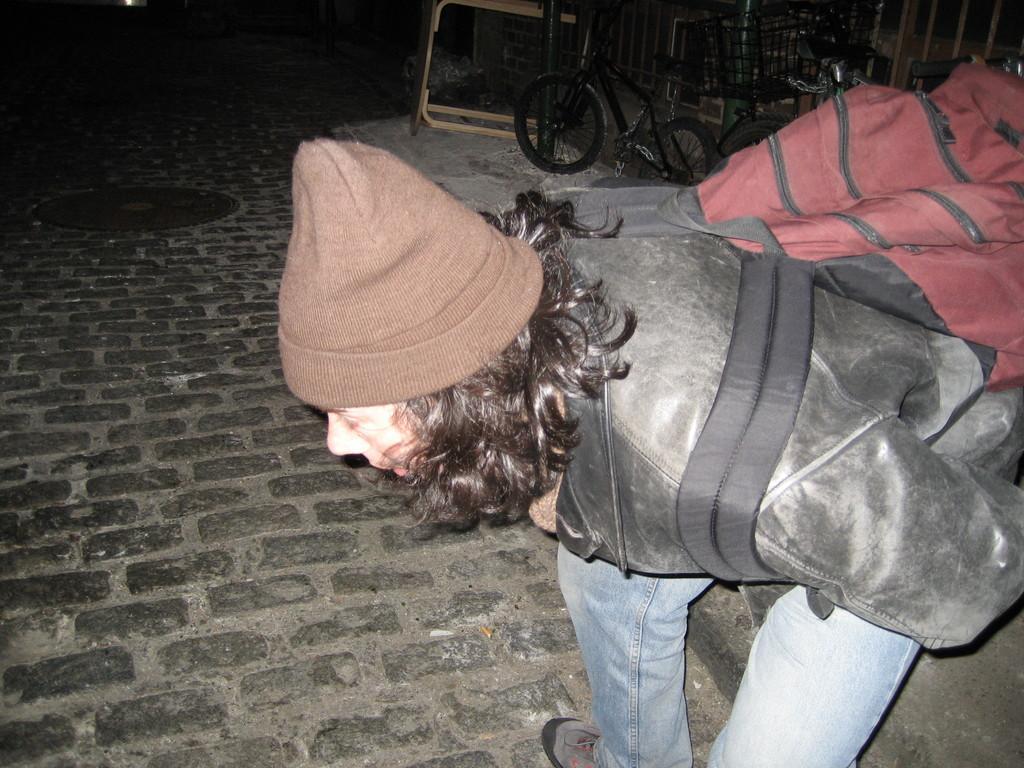Can you describe this image briefly? This is outdoor picture. On the background of the picture we can see a a table and beside that there is a bicycle with a basket and here we can see a man bending and looking toward the ground and the man is highlighted in the picture. Man is wearing a backpack which is red in colour and is wearing a jacket which is black in colour. He wore a cap which is brown in colour. Here we can see a drainage cap. 